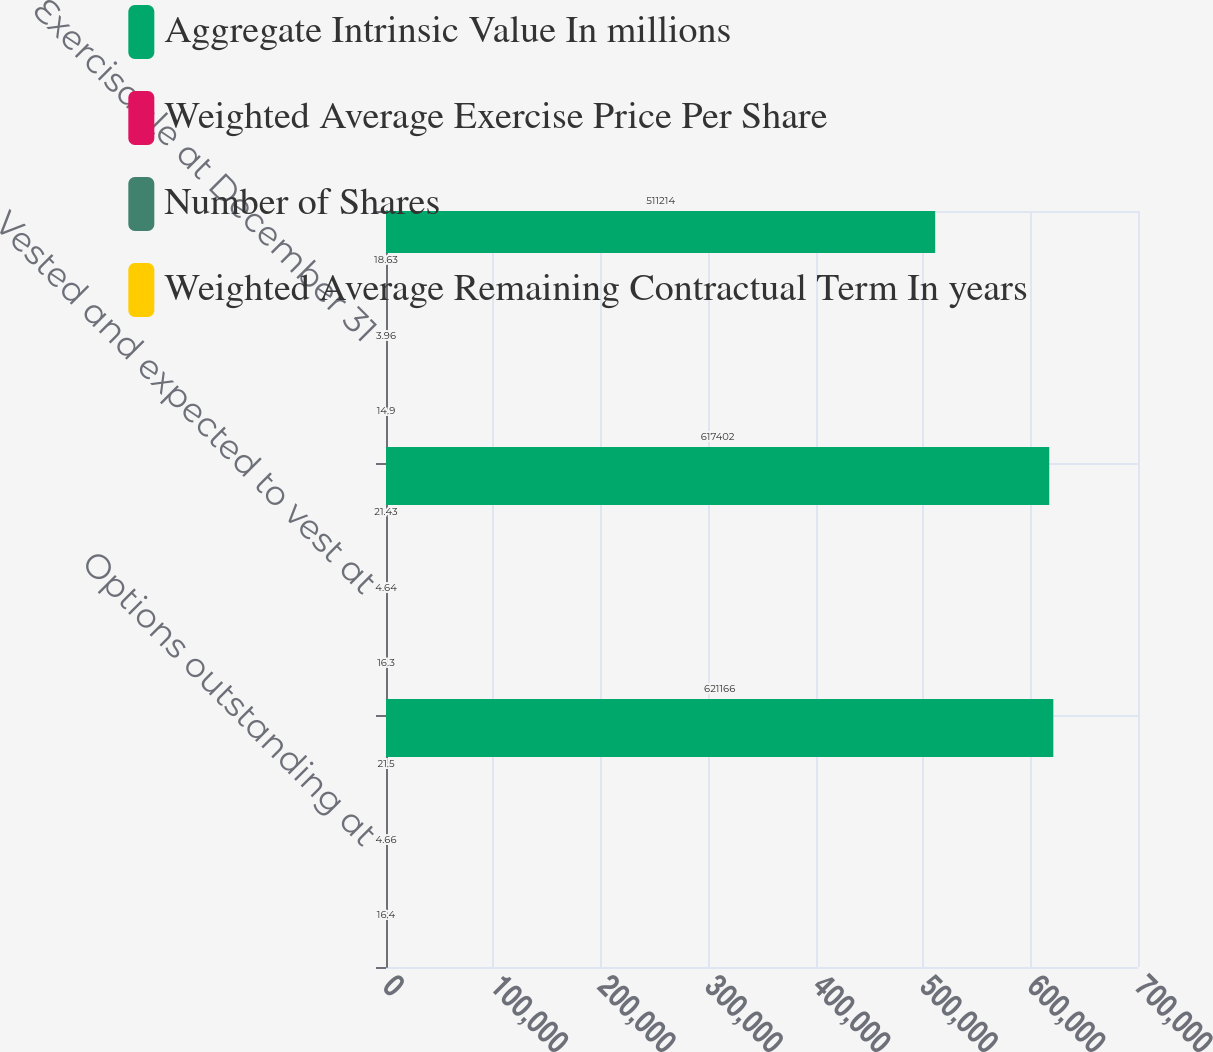Convert chart to OTSL. <chart><loc_0><loc_0><loc_500><loc_500><stacked_bar_chart><ecel><fcel>Options outstanding at<fcel>Vested and expected to vest at<fcel>Exercisable at December 31<nl><fcel>Aggregate Intrinsic Value In millions<fcel>621166<fcel>617402<fcel>511214<nl><fcel>Weighted Average Exercise Price Per Share<fcel>21.5<fcel>21.43<fcel>18.63<nl><fcel>Number of Shares<fcel>4.66<fcel>4.64<fcel>3.96<nl><fcel>Weighted Average Remaining Contractual Term In years<fcel>16.4<fcel>16.3<fcel>14.9<nl></chart> 